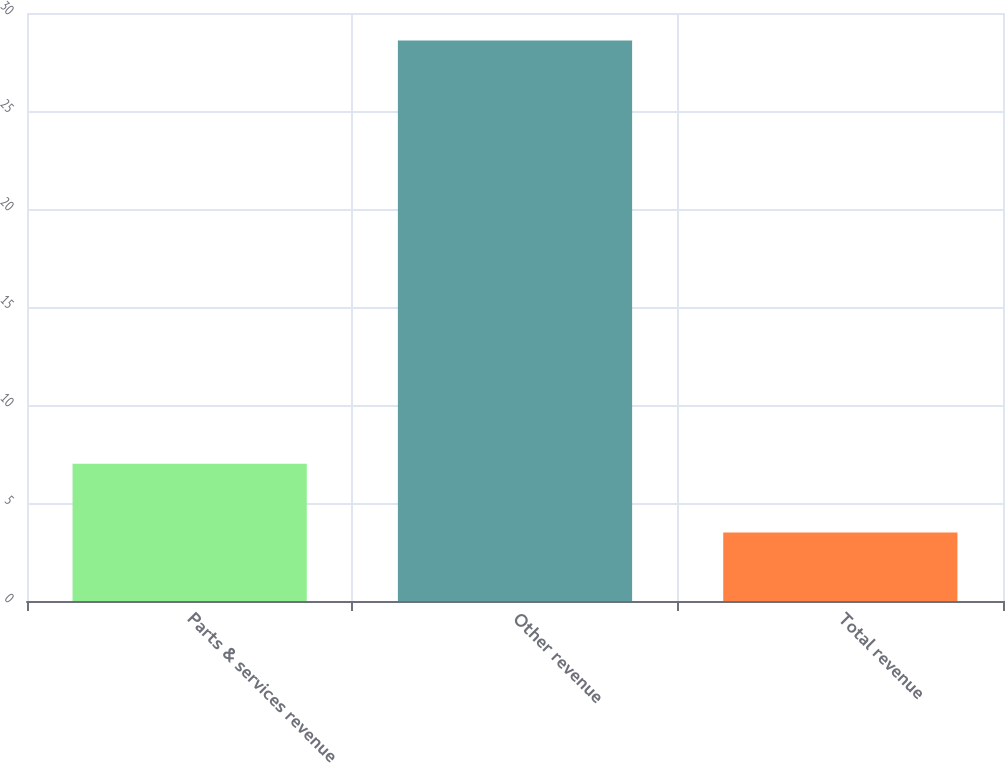<chart> <loc_0><loc_0><loc_500><loc_500><bar_chart><fcel>Parts & services revenue<fcel>Other revenue<fcel>Total revenue<nl><fcel>7<fcel>28.6<fcel>3.5<nl></chart> 